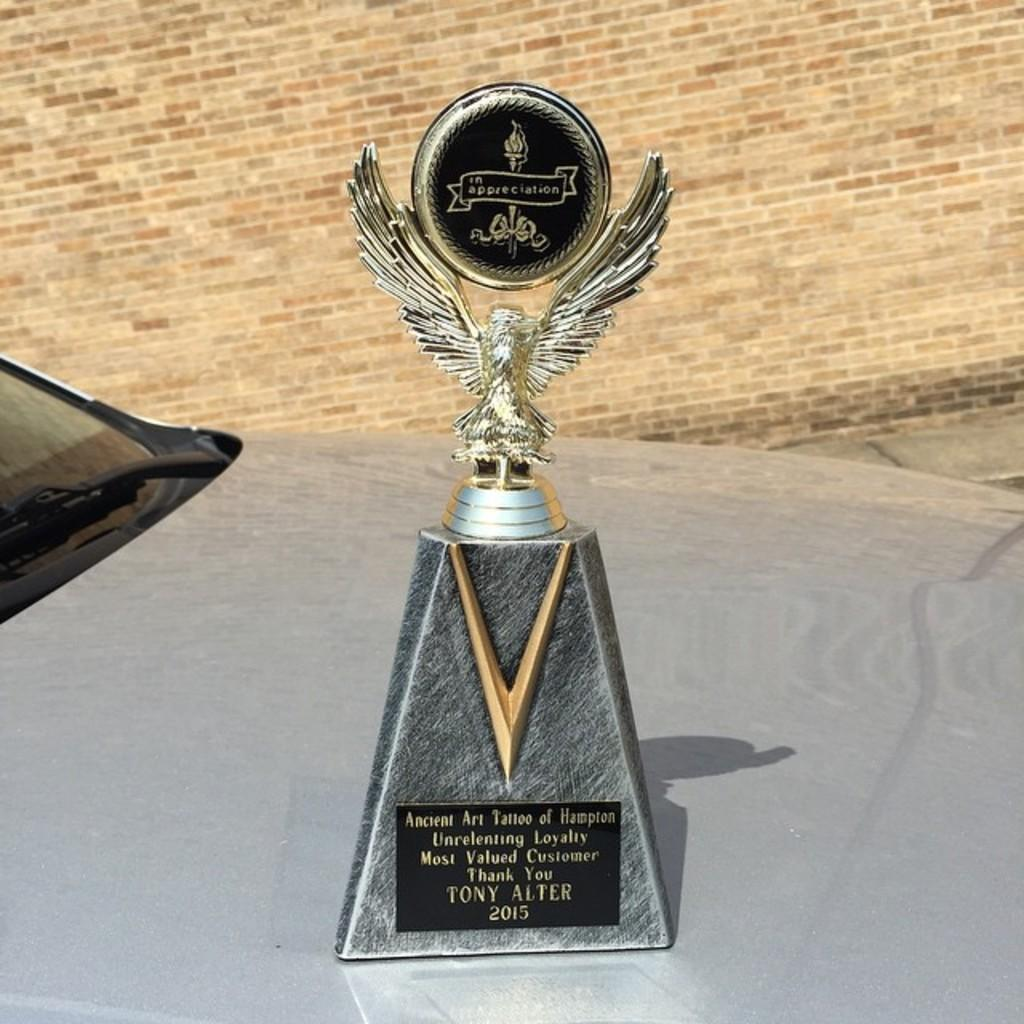<image>
Provide a brief description of the given image. A trophy for customer loyalty is sitting on top a car. 